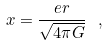<formula> <loc_0><loc_0><loc_500><loc_500>x = \frac { e r } { \sqrt { 4 \pi G } } \ ,</formula> 